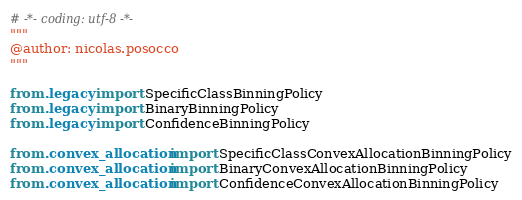<code> <loc_0><loc_0><loc_500><loc_500><_Python_># -*- coding: utf-8 -*-
"""
@author: nicolas.posocco
"""

from .legacy import SpecificClassBinningPolicy
from .legacy import BinaryBinningPolicy
from .legacy import ConfidenceBinningPolicy

from .convex_allocation import SpecificClassConvexAllocationBinningPolicy
from .convex_allocation import BinaryConvexAllocationBinningPolicy
from .convex_allocation import ConfidenceConvexAllocationBinningPolicy


</code> 